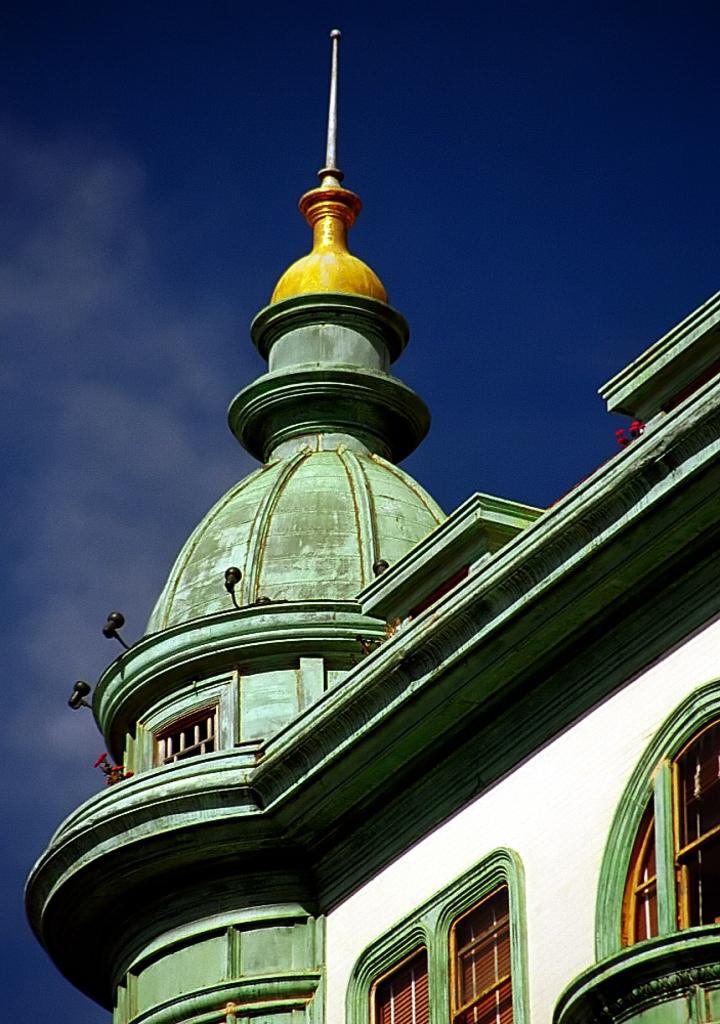What type of structure is shown in the image? The image depicts a building. What specific architectural feature can be seen on the building? There is a dome on the building. What is visible at the top of the image? The sky is visible at the top of the image. How many sponges can be seen on the dome of the building in the image? There are no sponges present on the dome of the building in the image. What type of pest is visible on the building in the image? There are no pests visible on the building in the image. 